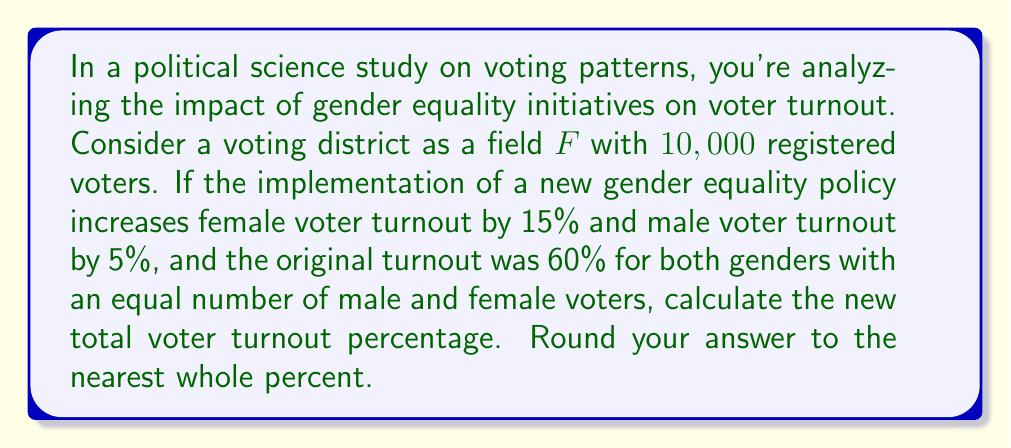Could you help me with this problem? Let's approach this step-by-step using field theory concepts:

1) Define the field $F$ as the set of all registered voters in the district.
   $|F| = 10,000$

2) Initially, the turnout was 60% for both genders. Let's calculate the initial number of voters:
   $\text{Initial voters} = 0.60 \times 10,000 = 6,000$

3) Since there are equal numbers of male and female voters:
   $\text{Initial female voters} = \text{Initial male voters} = 3,000$

4) After the policy implementation:
   New female turnout: $3,000 \times (1 + 0.15) = 3,450$
   New male turnout: $3,000 \times (1 + 0.05) = 3,150$

5) Total new turnout:
   $\text{New total turnout} = 3,450 + 3,150 = 6,600$

6) Calculate the new turnout percentage:
   $$\text{New turnout percentage} = \frac{6,600}{10,000} \times 100\% = 66\%$$

7) Round to the nearest whole percent: 66%

This problem demonstrates how policy changes can affect subfields (gender groups) within the larger field of voters, altering the overall characteristics of the field.
Answer: 66% 